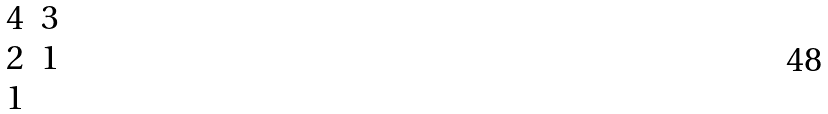<formula> <loc_0><loc_0><loc_500><loc_500>\begin{matrix} 4 & 3 \\ 2 & 1 \\ 1 \end{matrix}</formula> 